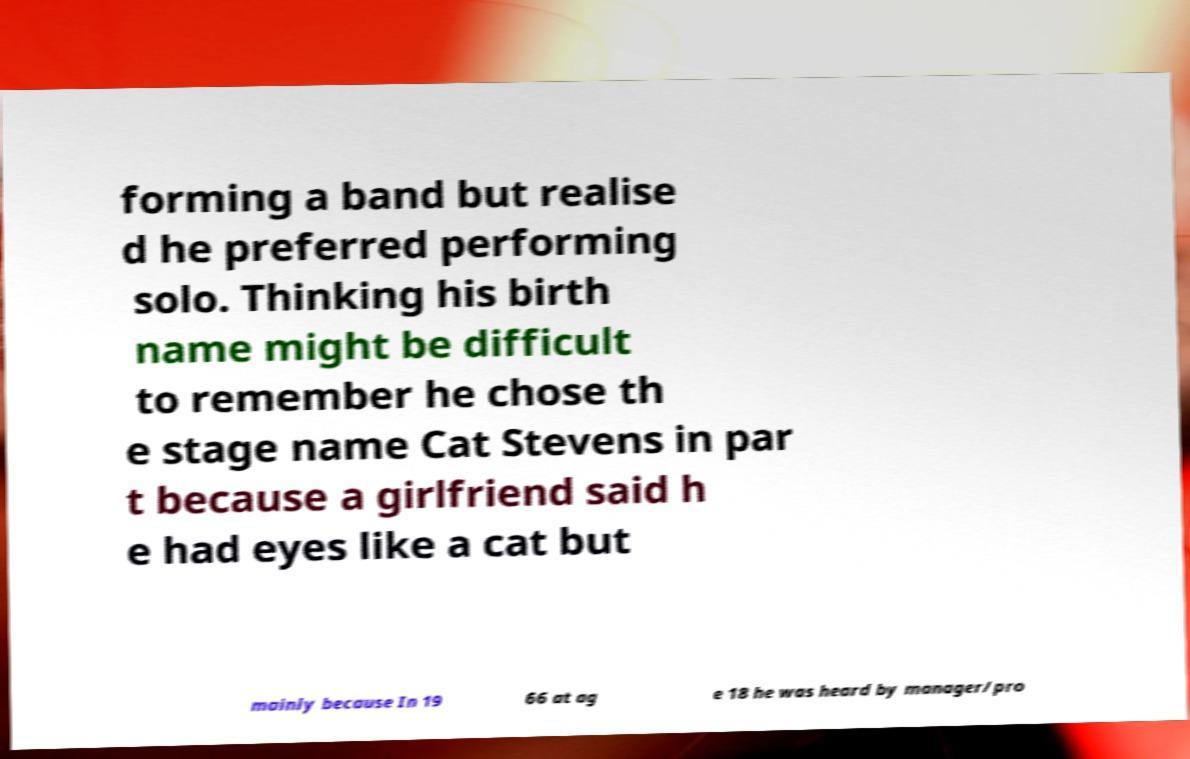Can you accurately transcribe the text from the provided image for me? forming a band but realise d he preferred performing solo. Thinking his birth name might be difficult to remember he chose th e stage name Cat Stevens in par t because a girlfriend said h e had eyes like a cat but mainly because In 19 66 at ag e 18 he was heard by manager/pro 